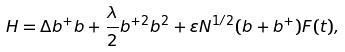<formula> <loc_0><loc_0><loc_500><loc_500>H = \Delta b ^ { + } b + \frac { \lambda } { 2 } b ^ { + 2 } b ^ { 2 } + \varepsilon N ^ { 1 / 2 } ( b + b ^ { + } ) F ( t ) ,</formula> 